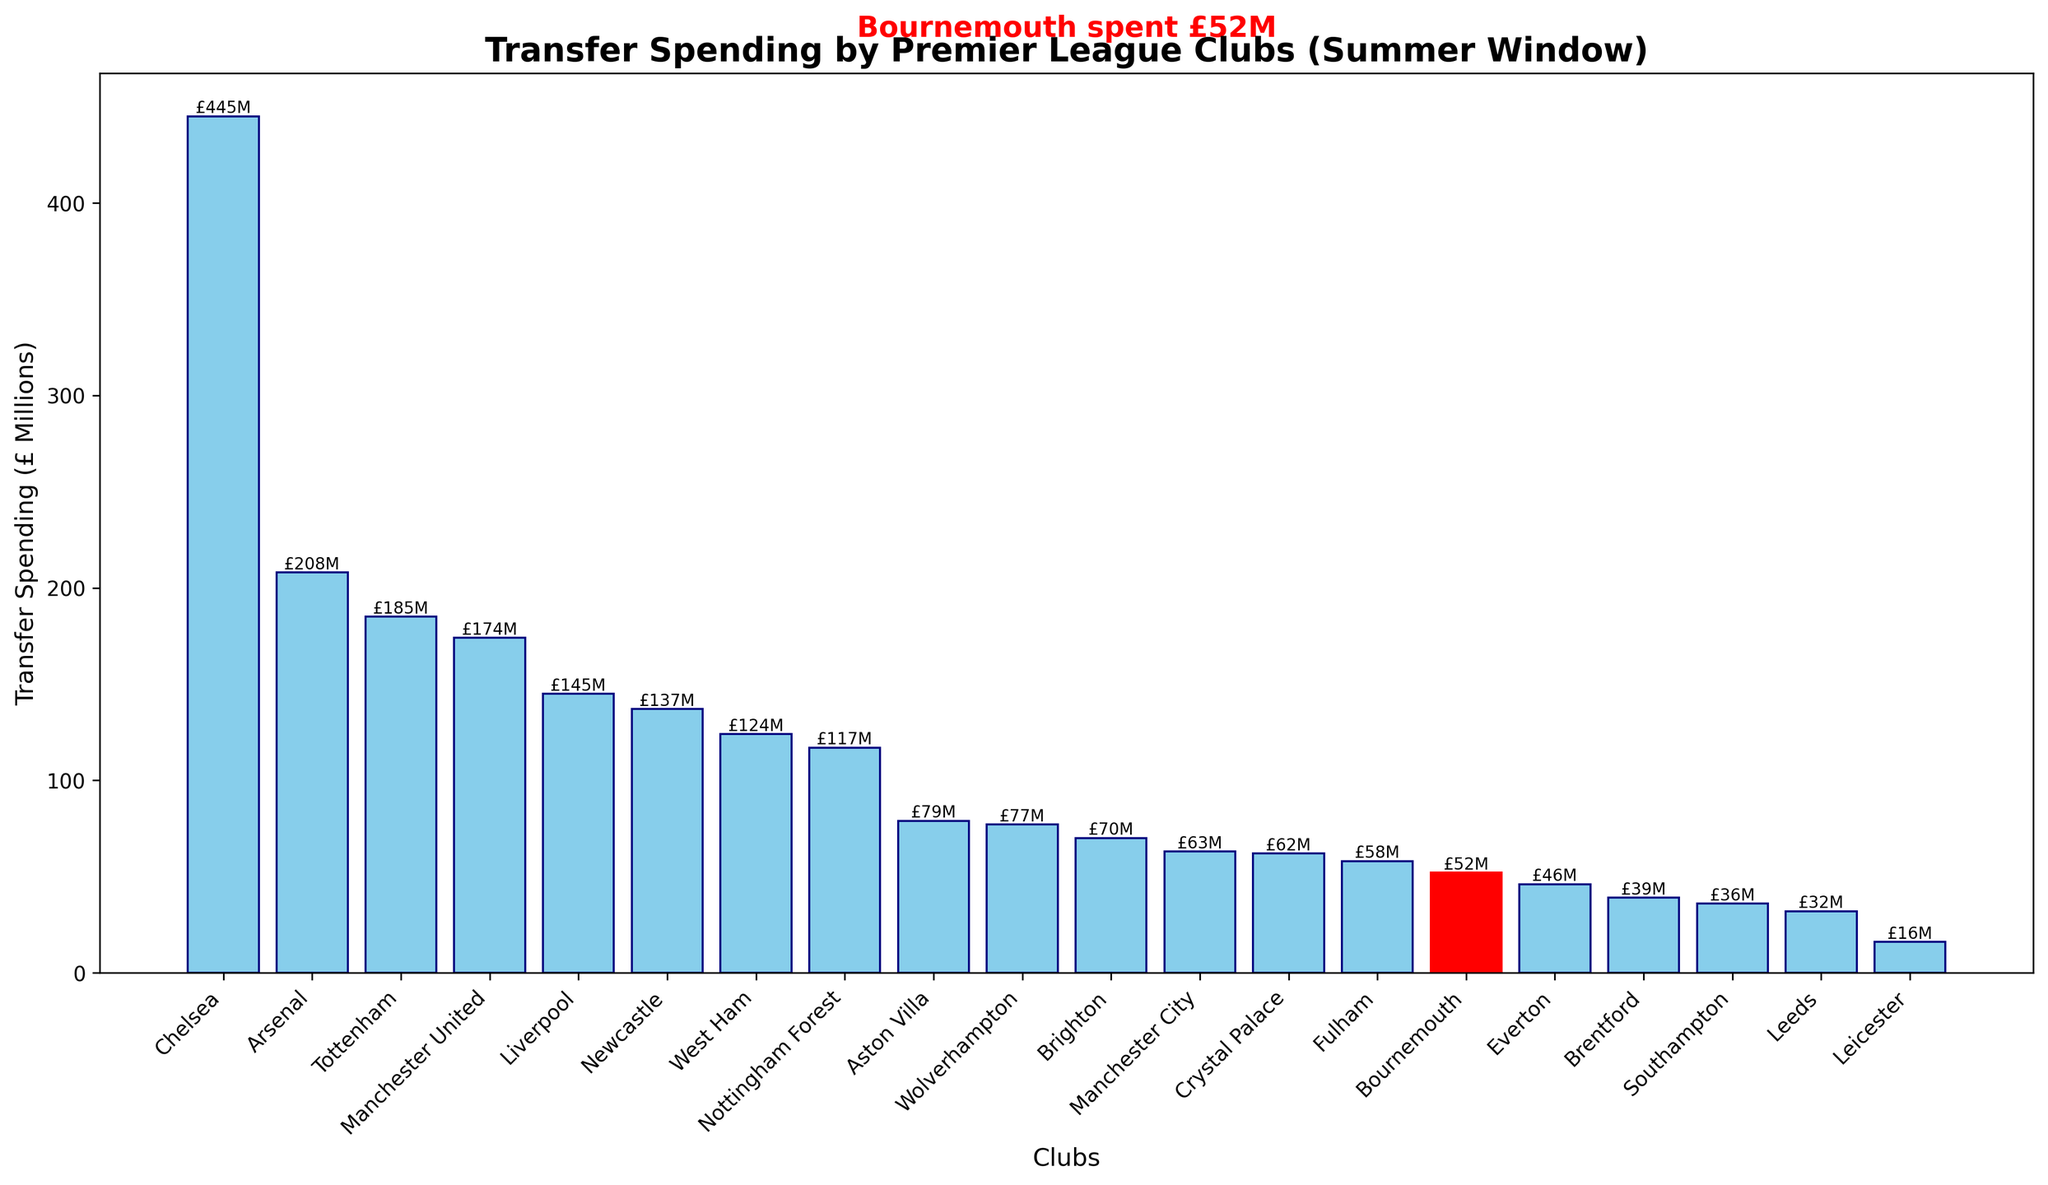How much did Bournemouth spend on transfers in the last summer window? The figure highlights Bournemouth's transfer spending in red and annotates its value.  Bournemouth spent £52 million.
Answer: £52 million Which club had the highest transfer spending? Observe the bar that reaches the highest point on the figure. Chelsea has the highest transfer spending, indicated by the tallest bar.
Answer: Chelsea What is the difference in transfer spending between Chelsea and Bournemouth? Subtract Bournemouth's transfer spending from Chelsea's. Chelsea spent £445 million, and Bournemouth spent £52 million. The difference is £445M - £52M = £393M.
Answer: £393 million How many clubs spent more than £100 million in the last summer window? Count the bars that extend beyond the £100 million mark. There are 8 clubs: Chelsea, Arsenal, Tottenham, Manchester United, Liverpool, Newcastle, West Ham, and Nottingham Forest.
Answer: 8 Compare Bournemouth's transfer spending to that of Manchester City. Which club spent more and by how much? Subtract Bournemouth's spending from Manchester City's. Manchester City spent £63 million while Bournemouth spent £52 million. The difference is £63M - £52M = £11M. Manchester City spent more.
Answer: Manchester City by £11 million What's the average transfer spending of the clubs shown? Sum all the transfer spending amounts and divide by the number of clubs (20). (445 + 208 + 185 + 174 + 145 + 137 + 124 + 117 + 79 + 77 + 70 + 63 + 62 + 58 + 52 + 46 + 39 + 36 + 32 + 16) / 20 = 2230 / 20 = £111.5 million
Answer: £111.5 million Which club spent the least on transfers? Observe the shortest bar on the graph. Leicester has the smallest bar representing the least spending.
Answer: Leicester How does Bournemouth's transfer spending compare to the median spending of the clubs? To find the median, list all spending amounts in numerical order and find the middle value. Here, the middle values are 63 and 62, so the median is (63 + 62) / 2 = £62.5 million. Bournemouth spent £52 million, which is below the median.
Answer: Below the median (£62.5 million) Which clubs spent between £50 million and £100 million? Identify the bars that fall between the £50 million and £100 million marks. The clubs are Aston Villa, Wolverhampton, Brighton, Crystal Palace, Fulham, and Bournemouth.
Answer: Aston Villa, Wolverhampton, Brighton, Crystal Palace, Fulham, Bournemouth What is the sum of transfer spending by the top 3 spending clubs? Add the amounts of the top 3 spending clubs: Chelsea, Arsenal, and Tottenham. 445 + 208 + 185 = £838 million.
Answer: £838 million 